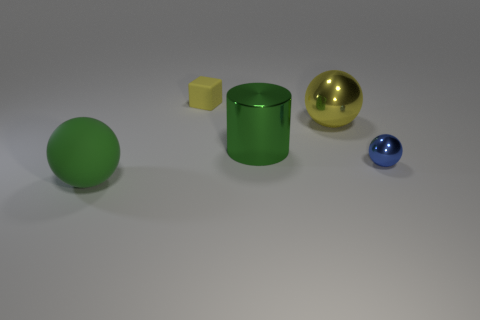Is there a metal thing of the same size as the yellow metal sphere?
Offer a very short reply. Yes. Is the big cylinder the same color as the large rubber thing?
Your response must be concise. Yes. What is the color of the matte thing on the right side of the matte thing on the left side of the small yellow matte cube?
Provide a short and direct response. Yellow. How many things are behind the tiny ball and right of the metal cylinder?
Your response must be concise. 1. What number of other yellow objects have the same shape as the big rubber thing?
Your response must be concise. 1. Are the small yellow thing and the tiny blue object made of the same material?
Offer a terse response. No. There is a tiny thing that is to the left of the big sphere that is right of the large rubber sphere; what shape is it?
Offer a terse response. Cube. What number of things are right of the sphere that is on the left side of the tiny yellow cube?
Make the answer very short. 4. The thing that is both left of the green cylinder and in front of the yellow rubber block is made of what material?
Your response must be concise. Rubber. What is the shape of the yellow metal thing that is the same size as the green metal thing?
Give a very brief answer. Sphere. 